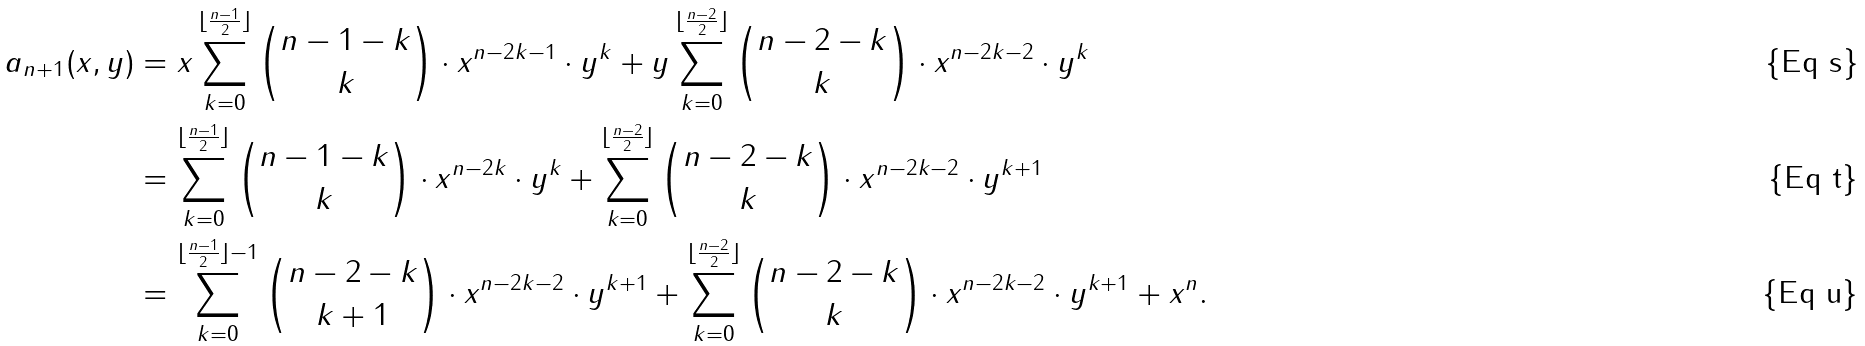Convert formula to latex. <formula><loc_0><loc_0><loc_500><loc_500>a _ { n + 1 } ( x , y ) & = x \sum _ { k = 0 } ^ { \lfloor \frac { n - 1 } { 2 } \rfloor } { n - 1 - k \choose k } \cdot x ^ { n - 2 k - 1 } \cdot y ^ { k } + y \sum _ { k = 0 } ^ { \lfloor \frac { n - 2 } { 2 } \rfloor } { n - 2 - k \choose k } \cdot x ^ { n - 2 k - 2 } \cdot y ^ { k } \\ & = \sum _ { k = 0 } ^ { \lfloor \frac { n - 1 } { 2 } \rfloor } { n - 1 - k \choose k } \cdot x ^ { n - 2 k } \cdot y ^ { k } + \sum _ { k = 0 } ^ { \lfloor \frac { n - 2 } { 2 } \rfloor } { n - 2 - k \choose k } \cdot x ^ { n - 2 k - 2 } \cdot y ^ { k + 1 } \\ & = \sum _ { k = 0 } ^ { \lfloor \frac { n - 1 } { 2 } \rfloor - 1 } { n - 2 - k \choose k + 1 } \cdot x ^ { n - 2 k - 2 } \cdot y ^ { k + 1 } + \sum _ { k = 0 } ^ { \lfloor \frac { n - 2 } { 2 } \rfloor } { n - 2 - k \choose k } \cdot x ^ { n - 2 k - 2 } \cdot y ^ { k + 1 } + x ^ { n } .</formula> 